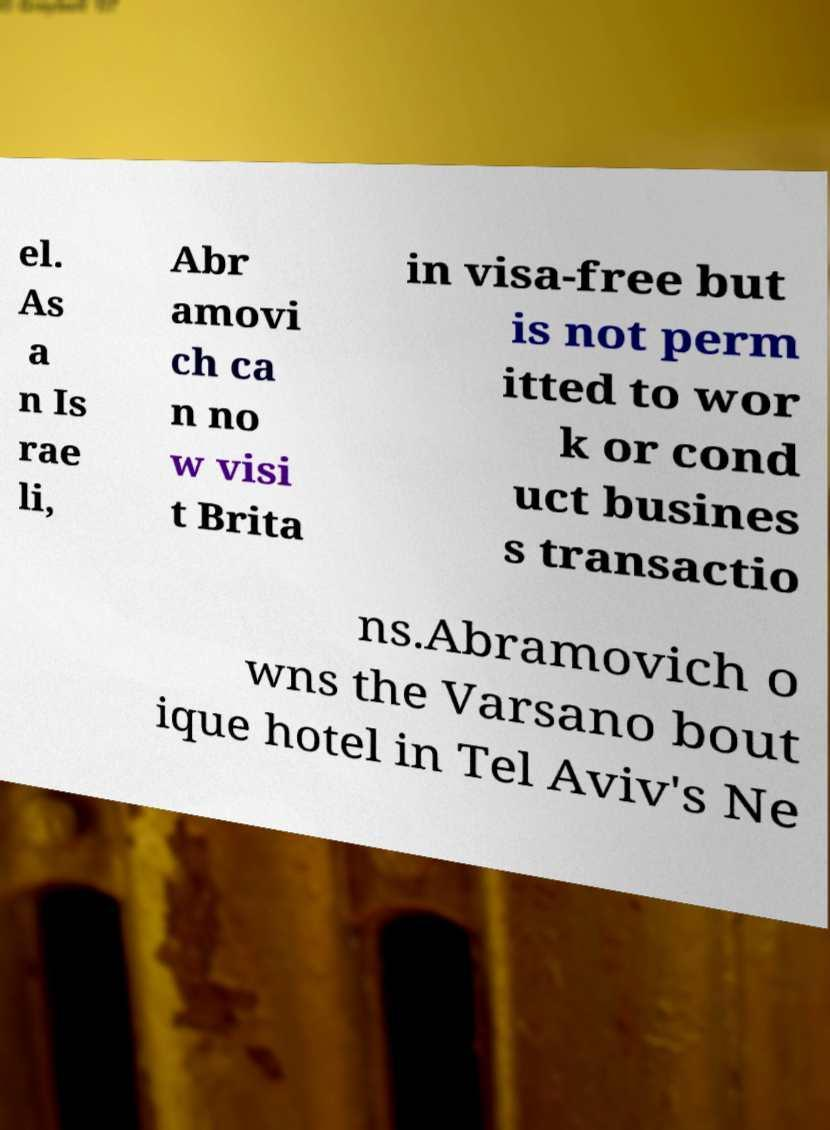For documentation purposes, I need the text within this image transcribed. Could you provide that? el. As a n Is rae li, Abr amovi ch ca n no w visi t Brita in visa-free but is not perm itted to wor k or cond uct busines s transactio ns.Abramovich o wns the Varsano bout ique hotel in Tel Aviv's Ne 